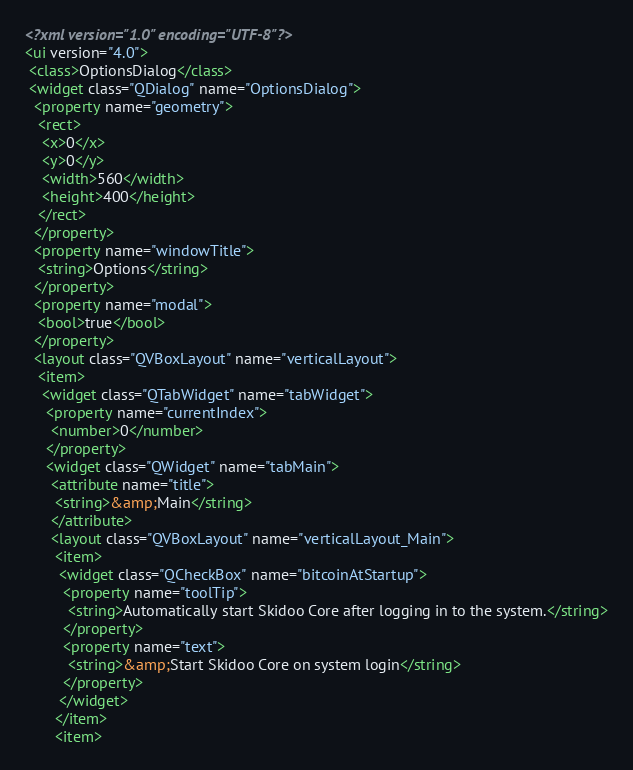<code> <loc_0><loc_0><loc_500><loc_500><_XML_><?xml version="1.0" encoding="UTF-8"?>
<ui version="4.0">
 <class>OptionsDialog</class>
 <widget class="QDialog" name="OptionsDialog">
  <property name="geometry">
   <rect>
    <x>0</x>
    <y>0</y>
    <width>560</width>
    <height>400</height>
   </rect>
  </property>
  <property name="windowTitle">
   <string>Options</string>
  </property>
  <property name="modal">
   <bool>true</bool>
  </property>
  <layout class="QVBoxLayout" name="verticalLayout">
   <item>
    <widget class="QTabWidget" name="tabWidget">
     <property name="currentIndex">
      <number>0</number>
     </property>
     <widget class="QWidget" name="tabMain">
      <attribute name="title">
       <string>&amp;Main</string>
      </attribute>
      <layout class="QVBoxLayout" name="verticalLayout_Main">
       <item>
        <widget class="QCheckBox" name="bitcoinAtStartup">
         <property name="toolTip">
          <string>Automatically start Skidoo Core after logging in to the system.</string>
         </property>
         <property name="text">
          <string>&amp;Start Skidoo Core on system login</string>
         </property>
        </widget>
       </item>
       <item></code> 